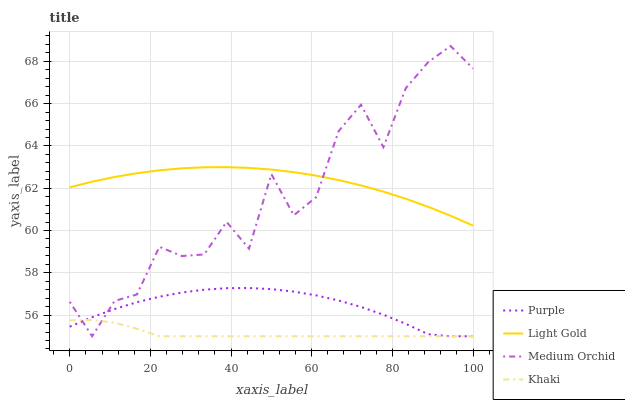Does Khaki have the minimum area under the curve?
Answer yes or no. Yes. Does Light Gold have the maximum area under the curve?
Answer yes or no. Yes. Does Medium Orchid have the minimum area under the curve?
Answer yes or no. No. Does Medium Orchid have the maximum area under the curve?
Answer yes or no. No. Is Light Gold the smoothest?
Answer yes or no. Yes. Is Medium Orchid the roughest?
Answer yes or no. Yes. Is Medium Orchid the smoothest?
Answer yes or no. No. Is Light Gold the roughest?
Answer yes or no. No. Does Purple have the lowest value?
Answer yes or no. Yes. Does Light Gold have the lowest value?
Answer yes or no. No. Does Medium Orchid have the highest value?
Answer yes or no. Yes. Does Light Gold have the highest value?
Answer yes or no. No. Is Khaki less than Light Gold?
Answer yes or no. Yes. Is Light Gold greater than Purple?
Answer yes or no. Yes. Does Purple intersect Khaki?
Answer yes or no. Yes. Is Purple less than Khaki?
Answer yes or no. No. Is Purple greater than Khaki?
Answer yes or no. No. Does Khaki intersect Light Gold?
Answer yes or no. No. 